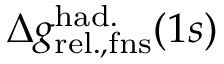Convert formula to latex. <formula><loc_0><loc_0><loc_500><loc_500>\Delta { g } _ { r e l . , f n s } ^ { h a d . } ( 1 s )</formula> 